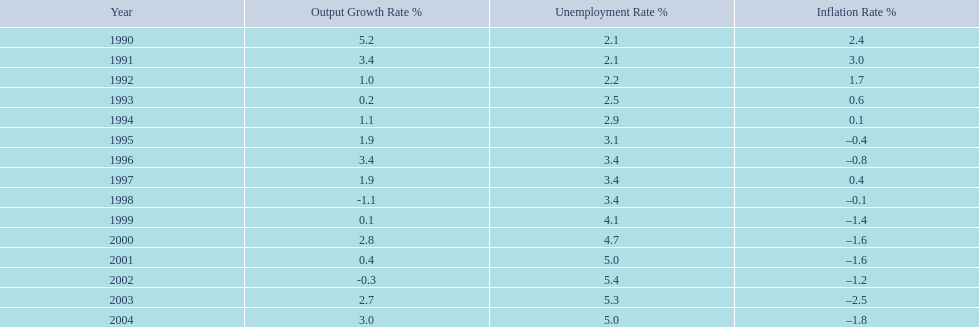Did japan experience the most elevated unemployment rates before or after 2000? After. 